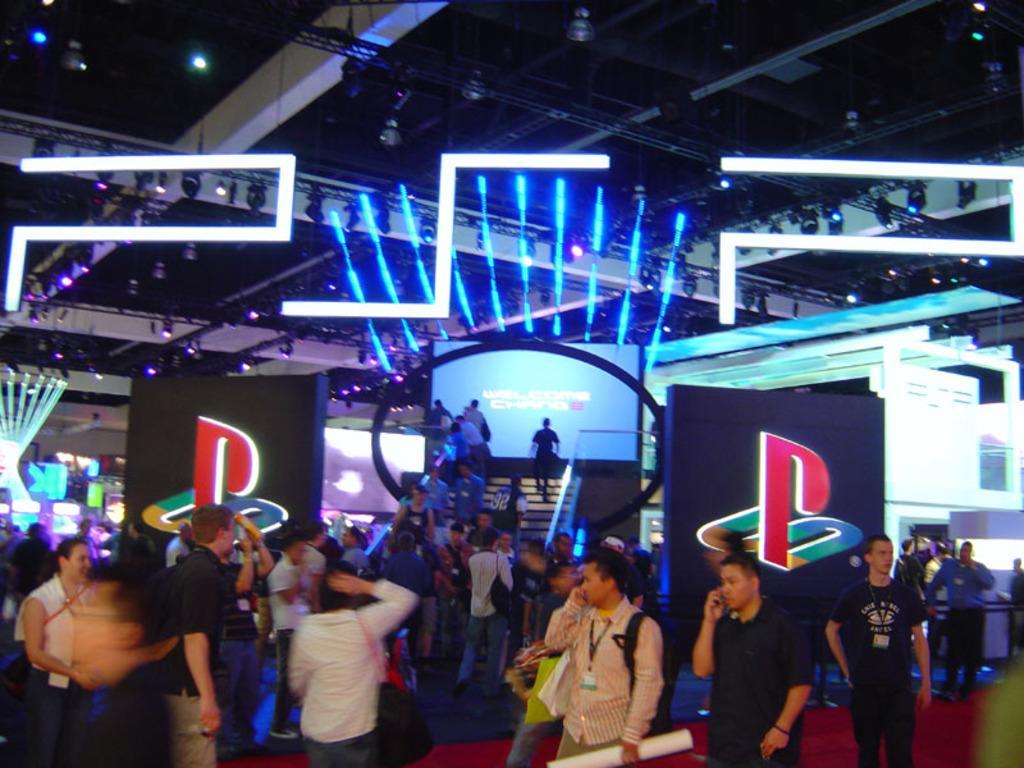Please provide a concise description of this image. In this picture we can see some people are standing on the floor and some people are walking on the steps. Behind the people there are boards and it looks like a screen. At the top there are lights and trusses. 